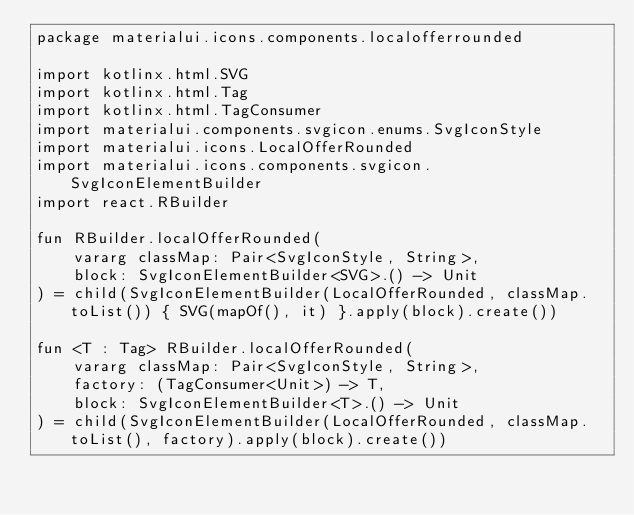Convert code to text. <code><loc_0><loc_0><loc_500><loc_500><_Kotlin_>package materialui.icons.components.localofferrounded

import kotlinx.html.SVG
import kotlinx.html.Tag
import kotlinx.html.TagConsumer
import materialui.components.svgicon.enums.SvgIconStyle
import materialui.icons.LocalOfferRounded
import materialui.icons.components.svgicon.SvgIconElementBuilder
import react.RBuilder

fun RBuilder.localOfferRounded(
    vararg classMap: Pair<SvgIconStyle, String>,
    block: SvgIconElementBuilder<SVG>.() -> Unit
) = child(SvgIconElementBuilder(LocalOfferRounded, classMap.toList()) { SVG(mapOf(), it) }.apply(block).create())

fun <T : Tag> RBuilder.localOfferRounded(
    vararg classMap: Pair<SvgIconStyle, String>,
    factory: (TagConsumer<Unit>) -> T,
    block: SvgIconElementBuilder<T>.() -> Unit
) = child(SvgIconElementBuilder(LocalOfferRounded, classMap.toList(), factory).apply(block).create())
</code> 